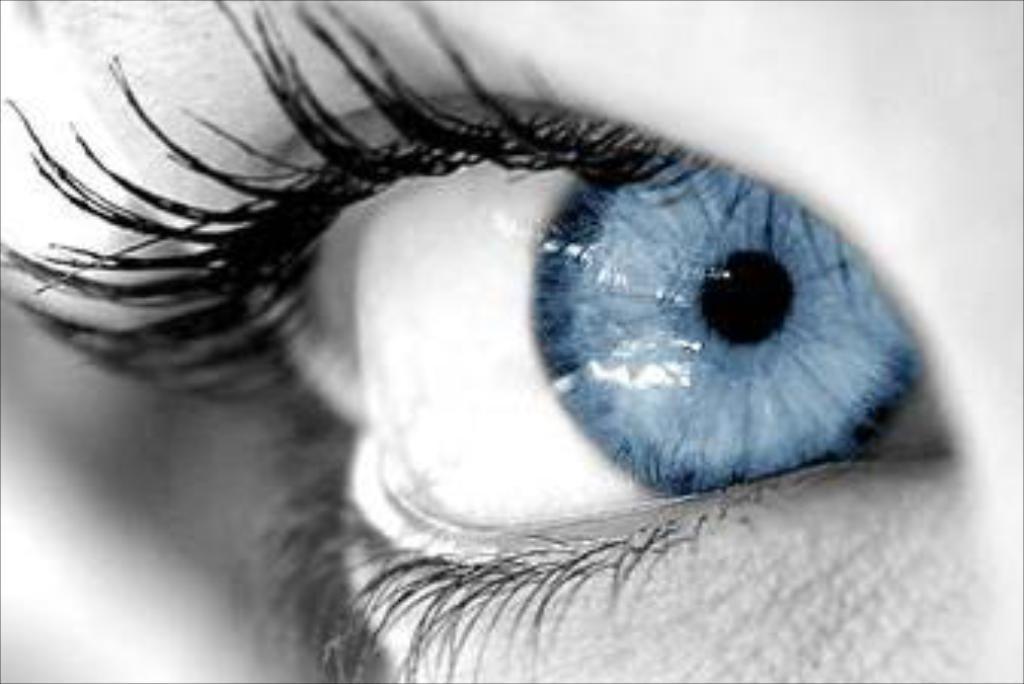In one or two sentences, can you explain what this image depicts? In this picture there is an eye in the center of the image. 